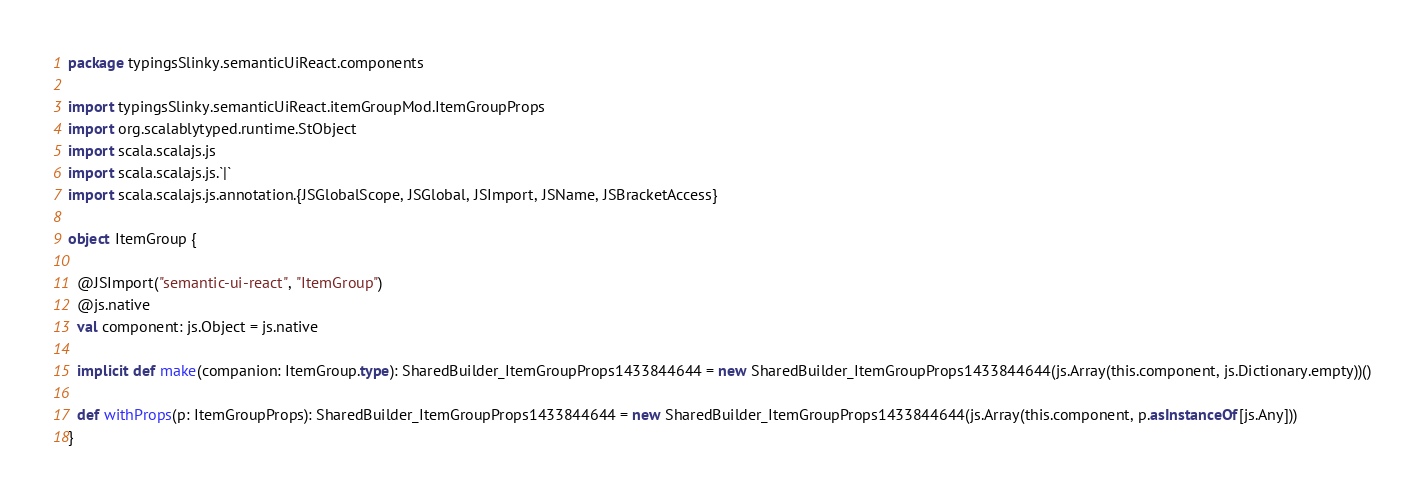Convert code to text. <code><loc_0><loc_0><loc_500><loc_500><_Scala_>package typingsSlinky.semanticUiReact.components

import typingsSlinky.semanticUiReact.itemGroupMod.ItemGroupProps
import org.scalablytyped.runtime.StObject
import scala.scalajs.js
import scala.scalajs.js.`|`
import scala.scalajs.js.annotation.{JSGlobalScope, JSGlobal, JSImport, JSName, JSBracketAccess}

object ItemGroup {
  
  @JSImport("semantic-ui-react", "ItemGroup")
  @js.native
  val component: js.Object = js.native
  
  implicit def make(companion: ItemGroup.type): SharedBuilder_ItemGroupProps1433844644 = new SharedBuilder_ItemGroupProps1433844644(js.Array(this.component, js.Dictionary.empty))()
  
  def withProps(p: ItemGroupProps): SharedBuilder_ItemGroupProps1433844644 = new SharedBuilder_ItemGroupProps1433844644(js.Array(this.component, p.asInstanceOf[js.Any]))
}
</code> 